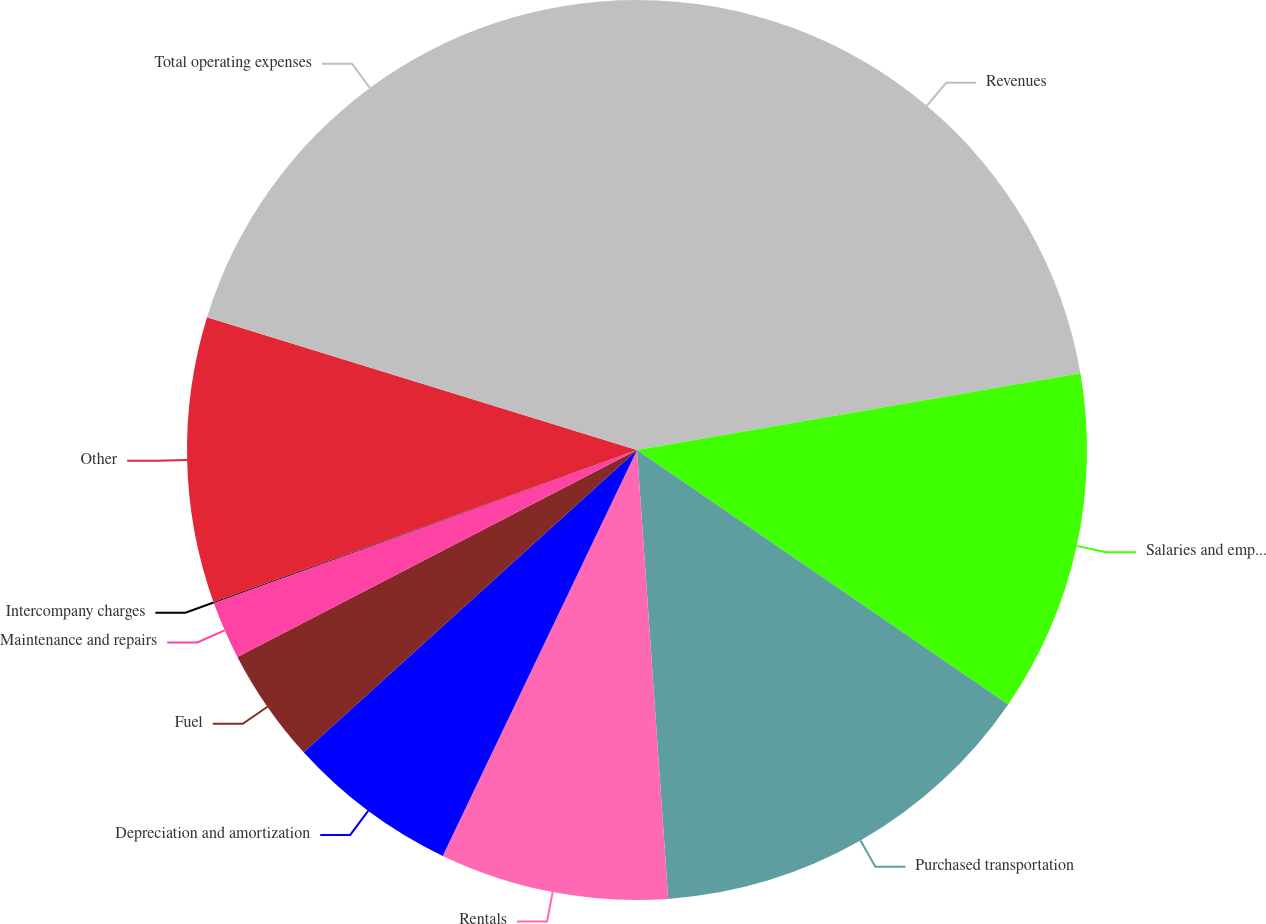Convert chart to OTSL. <chart><loc_0><loc_0><loc_500><loc_500><pie_chart><fcel>Revenues<fcel>Salaries and employee benefits<fcel>Purchased transportation<fcel>Rentals<fcel>Depreciation and amortization<fcel>Fuel<fcel>Maintenance and repairs<fcel>Intercompany charges<fcel>Other<fcel>Total operating expenses<nl><fcel>22.27%<fcel>12.29%<fcel>14.33%<fcel>8.21%<fcel>6.17%<fcel>4.12%<fcel>2.08%<fcel>0.04%<fcel>10.25%<fcel>20.23%<nl></chart> 